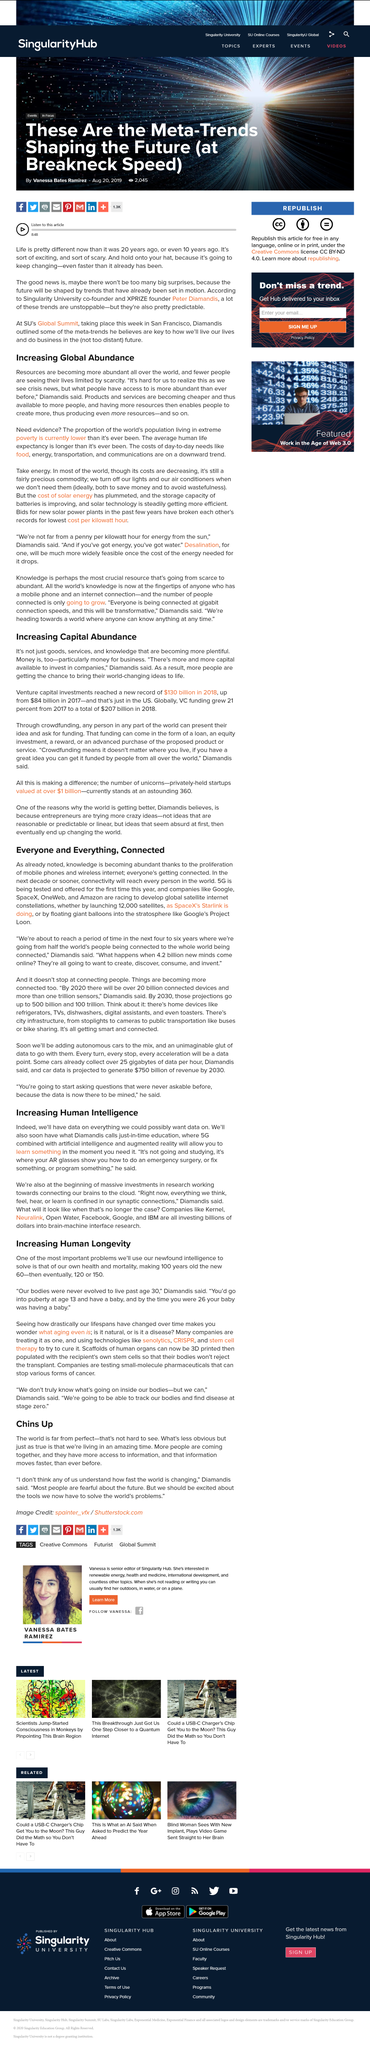Identify some key points in this picture. Global venture capital funding increased by 21% from 2017 to 2018. Several companies, such as Kernel, Neuralink, Open Water, Facebook, Google, and IBM, have invested billions of dollars into brain-machine interface research. In 2018, the amount of venture capital investments made in the United States was $130 billion. The costs of day-to-day necessities, such as food, energy, transportation, and communications, are on a downward trend. Companies are using technologies such as senolytics, CRISPR, and stem cell therapy to try and cure the process of ageing. 